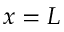<formula> <loc_0><loc_0><loc_500><loc_500>x = L</formula> 